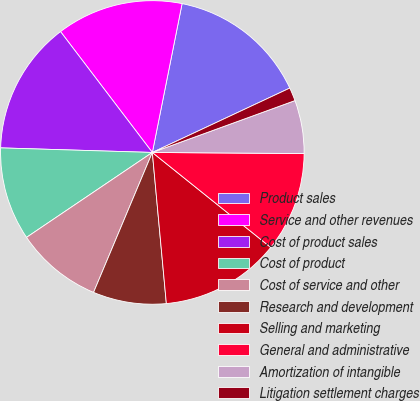<chart> <loc_0><loc_0><loc_500><loc_500><pie_chart><fcel>Product sales<fcel>Service and other revenues<fcel>Cost of product sales<fcel>Cost of product<fcel>Cost of service and other<fcel>Research and development<fcel>Selling and marketing<fcel>General and administrative<fcel>Amortization of intangible<fcel>Litigation settlement charges<nl><fcel>14.89%<fcel>13.48%<fcel>14.18%<fcel>9.93%<fcel>9.22%<fcel>7.8%<fcel>12.77%<fcel>10.64%<fcel>5.67%<fcel>1.42%<nl></chart> 